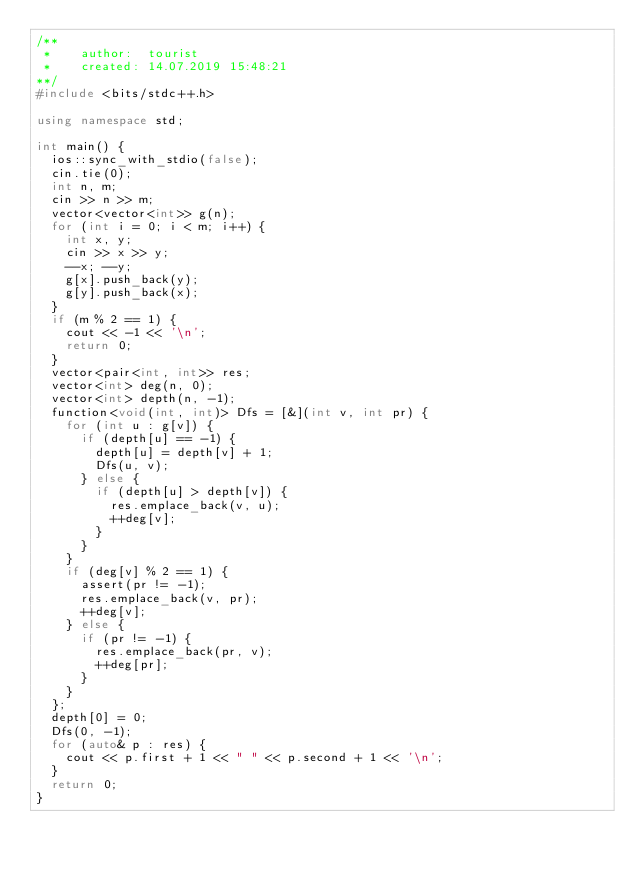<code> <loc_0><loc_0><loc_500><loc_500><_C++_>/**
 *    author:  tourist
 *    created: 14.07.2019 15:48:21       
**/
#include <bits/stdc++.h>

using namespace std;

int main() {
  ios::sync_with_stdio(false);
  cin.tie(0);
  int n, m;
  cin >> n >> m;
  vector<vector<int>> g(n);
  for (int i = 0; i < m; i++) {
    int x, y;
    cin >> x >> y;
    --x; --y;
    g[x].push_back(y);
    g[y].push_back(x);
  }
  if (m % 2 == 1) {
    cout << -1 << '\n';
    return 0;
  }
  vector<pair<int, int>> res;
  vector<int> deg(n, 0);
  vector<int> depth(n, -1);
  function<void(int, int)> Dfs = [&](int v, int pr) {
    for (int u : g[v]) {
      if (depth[u] == -1) {
        depth[u] = depth[v] + 1;
        Dfs(u, v);
      } else {
        if (depth[u] > depth[v]) {
          res.emplace_back(v, u);
          ++deg[v];
        }
      }
    }
    if (deg[v] % 2 == 1) {
      assert(pr != -1);
      res.emplace_back(v, pr);
      ++deg[v];
    } else {
      if (pr != -1) {
        res.emplace_back(pr, v);
        ++deg[pr];
      }
    }
  };
  depth[0] = 0;
  Dfs(0, -1);
  for (auto& p : res) {
    cout << p.first + 1 << " " << p.second + 1 << '\n';
  }
  return 0;
}
</code> 